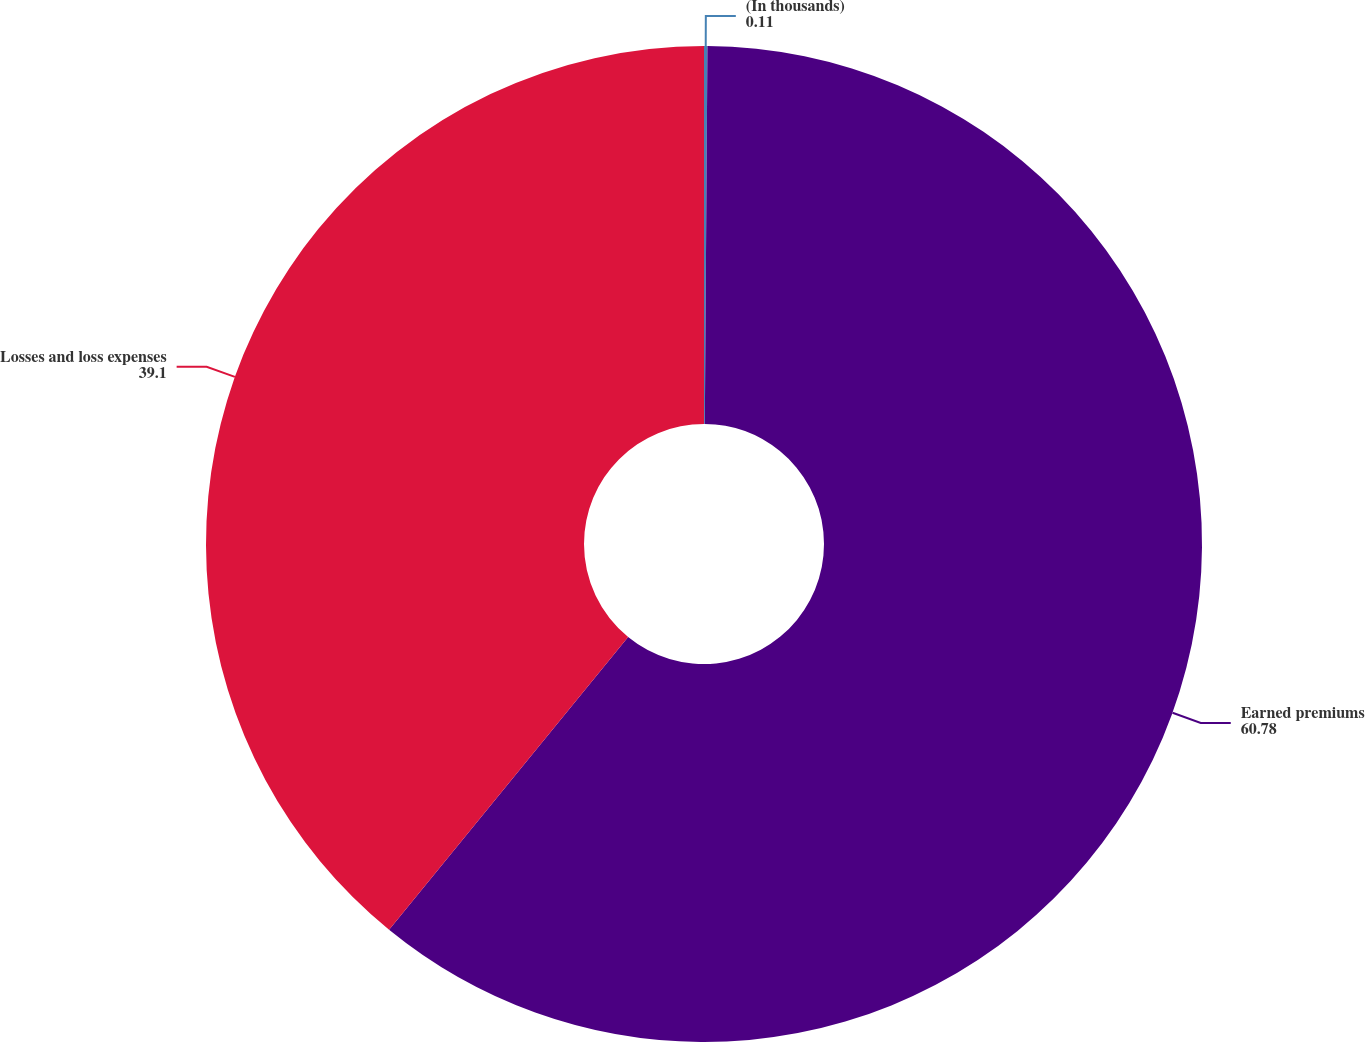Convert chart. <chart><loc_0><loc_0><loc_500><loc_500><pie_chart><fcel>(In thousands)<fcel>Earned premiums<fcel>Losses and loss expenses<nl><fcel>0.11%<fcel>60.78%<fcel>39.1%<nl></chart> 